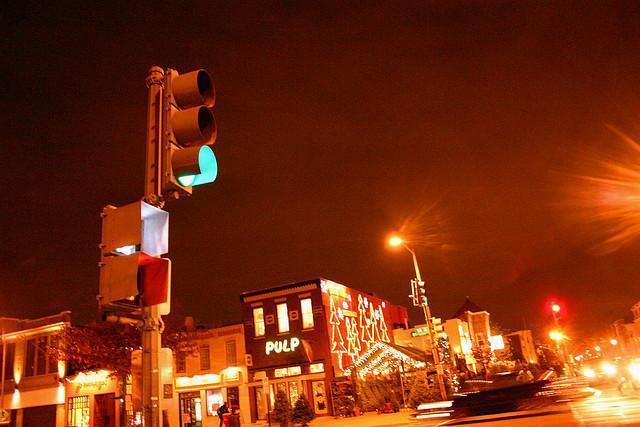How many traffic lights can you see?
Give a very brief answer. 2. 